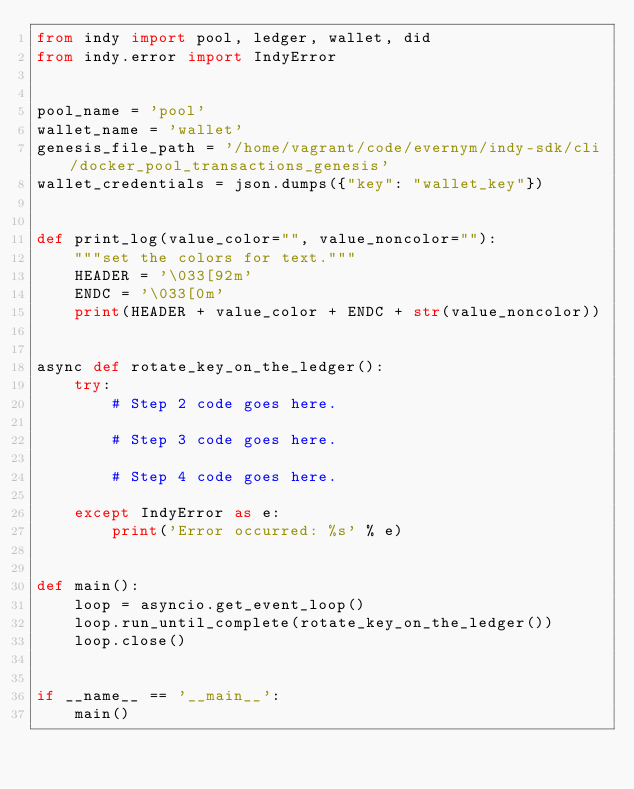Convert code to text. <code><loc_0><loc_0><loc_500><loc_500><_Python_>from indy import pool, ledger, wallet, did
from indy.error import IndyError


pool_name = 'pool'
wallet_name = 'wallet'
genesis_file_path = '/home/vagrant/code/evernym/indy-sdk/cli/docker_pool_transactions_genesis'
wallet_credentials = json.dumps({"key": "wallet_key"})


def print_log(value_color="", value_noncolor=""):
    """set the colors for text."""
    HEADER = '\033[92m'
    ENDC = '\033[0m'
    print(HEADER + value_color + ENDC + str(value_noncolor))


async def rotate_key_on_the_ledger():
    try:
        # Step 2 code goes here.

        # Step 3 code goes here.

        # Step 4 code goes here.

    except IndyError as e:
        print('Error occurred: %s' % e)


def main():
    loop = asyncio.get_event_loop()
    loop.run_until_complete(rotate_key_on_the_ledger())
    loop.close()


if __name__ == '__main__':
    main()

</code> 